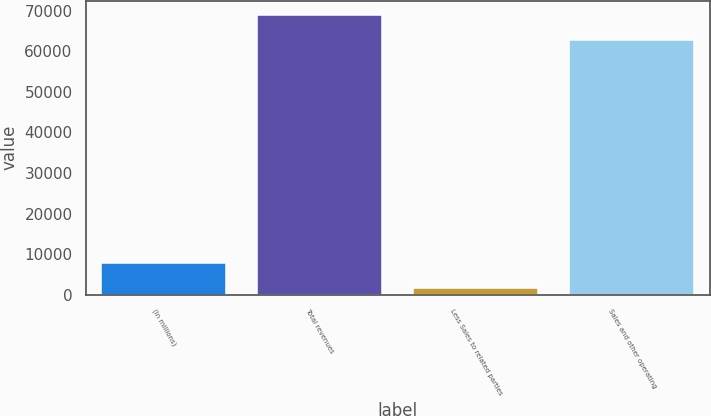Convert chart. <chart><loc_0><loc_0><loc_500><loc_500><bar_chart><fcel>(In millions)<fcel>Total revenues<fcel>Less Sales to related parties<fcel>Sales and other operating<nl><fcel>7917.7<fcel>69092.7<fcel>1625<fcel>62800<nl></chart> 